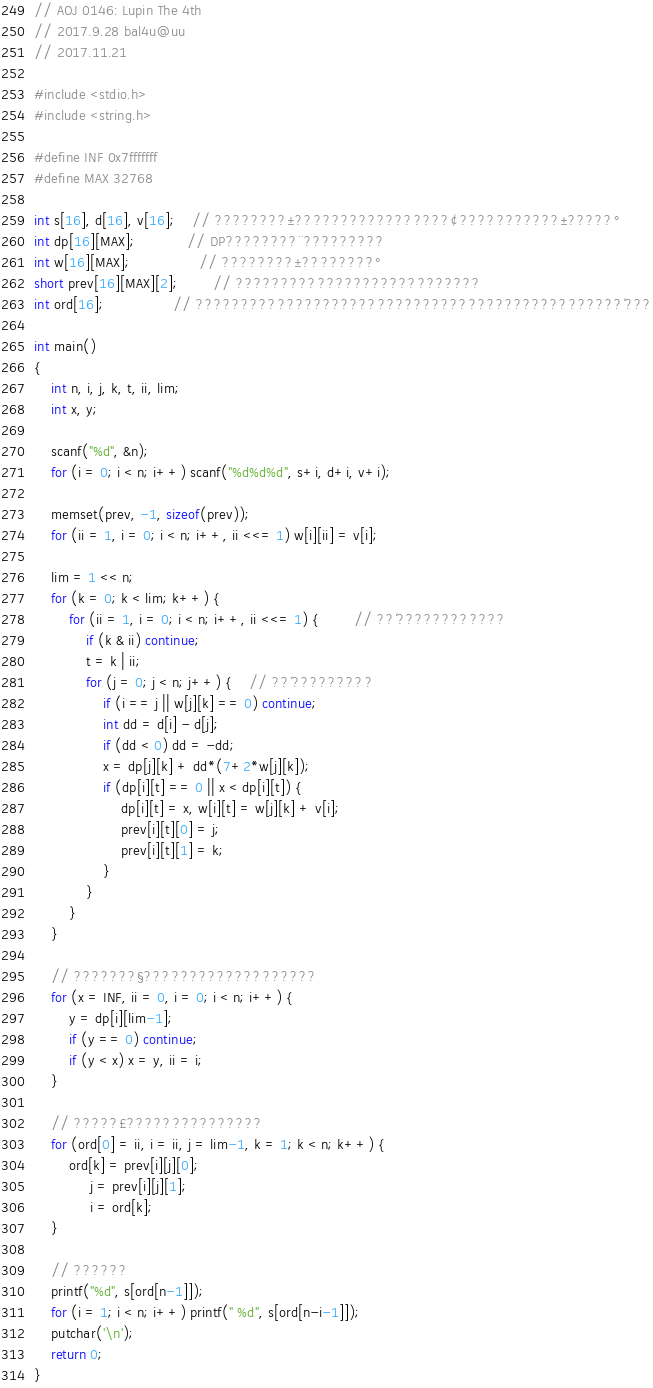<code> <loc_0><loc_0><loc_500><loc_500><_C_>// AOJ 0146: Lupin The 4th
// 2017.9.28 bal4u@uu
// 2017.11.21

#include <stdio.h>
#include <string.h>

#define INF 0x7fffffff
#define MAX 32768

int s[16], d[16], v[16];	// ????????±?????????????????¢???????????±?????°
int dp[16][MAX];			// DP????????¨?????????
int w[16][MAX];				// ????????±????????°
short prev[16][MAX][2];		// ???????????????????????????
int ord[16];				// ???????????????????????????????????????????????´???

int main()
{
	int n, i, j, k, t, ii, lim;
	int x, y;

	scanf("%d", &n);
	for (i = 0; i < n; i++) scanf("%d%d%d", s+i, d+i, v+i);

	memset(prev, -1, sizeof(prev));
	for (ii = 1, i = 0; i < n; i++, ii <<= 1) w[i][ii] = v[i];

	lim = 1 << n;
	for (k = 0; k < lim; k++) {
		for (ii = 1, i = 0; i < n; i++, ii <<= 1) {		// ??´????????????
			if (k & ii) continue;
			t = k | ii;
			for (j = 0; j < n; j++) {	// ??´?????????
				if (i == j || w[j][k] == 0) continue;
				int dd = d[i] - d[j];
				if (dd < 0) dd = -dd;
				x = dp[j][k] + dd*(7+2*w[j][k]);
				if (dp[i][t] == 0 || x < dp[i][t]) {
					dp[i][t] = x, w[i][t] = w[j][k] + v[i];
					prev[i][t][0] = j;
					prev[i][t][1] = k;
				}
			}
		}
	}

	// ???????§???????????????????
	for (x = INF, ii = 0, i = 0; i < n; i++) {
		y = dp[i][lim-1];
		if (y == 0) continue;
		if (y < x) x = y, ii = i;
	}

	// ?????£???????????????
	for (ord[0] = ii, i = ii, j = lim-1, k = 1; k < n; k++) {
		ord[k] = prev[i][j][0];
		     j = prev[i][j][1];
		     i = ord[k];
	}

	// ??????
	printf("%d", s[ord[n-1]]);
	for (i = 1; i < n; i++) printf(" %d", s[ord[n-i-1]]);
	putchar('\n');
	return 0;
}</code> 